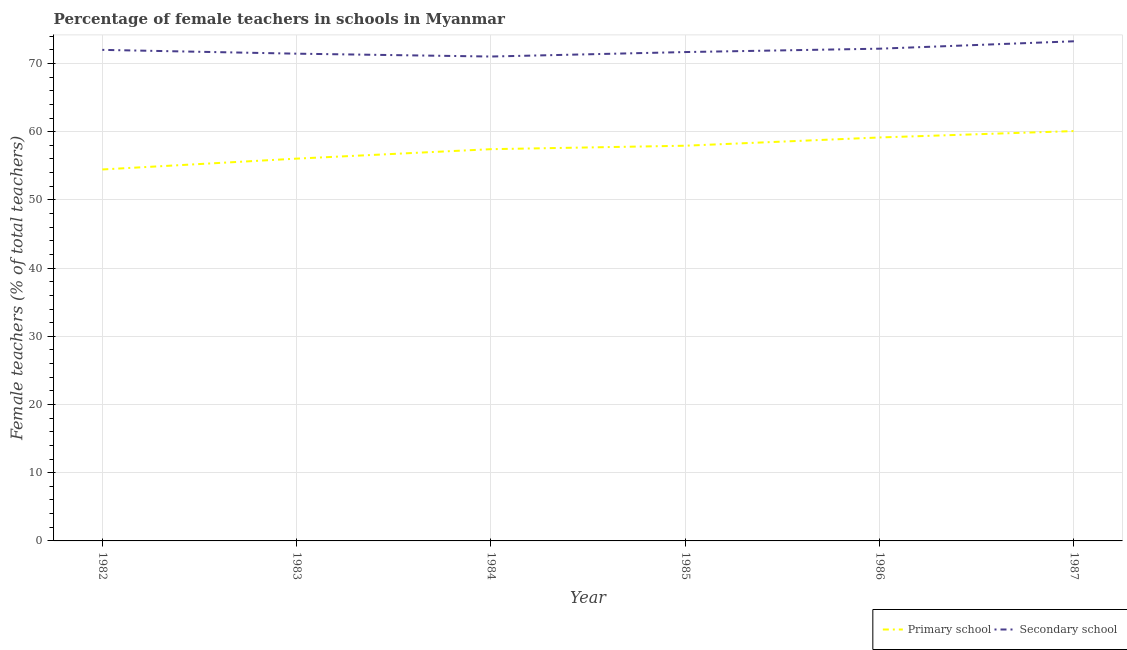Does the line corresponding to percentage of female teachers in secondary schools intersect with the line corresponding to percentage of female teachers in primary schools?
Offer a very short reply. No. What is the percentage of female teachers in primary schools in 1982?
Offer a very short reply. 54.46. Across all years, what is the maximum percentage of female teachers in secondary schools?
Offer a very short reply. 73.25. Across all years, what is the minimum percentage of female teachers in primary schools?
Provide a succinct answer. 54.46. In which year was the percentage of female teachers in secondary schools maximum?
Ensure brevity in your answer.  1987. What is the total percentage of female teachers in primary schools in the graph?
Keep it short and to the point. 345.13. What is the difference between the percentage of female teachers in secondary schools in 1984 and that in 1985?
Ensure brevity in your answer.  -0.66. What is the difference between the percentage of female teachers in primary schools in 1985 and the percentage of female teachers in secondary schools in 1983?
Offer a terse response. -13.49. What is the average percentage of female teachers in secondary schools per year?
Your answer should be very brief. 71.92. In the year 1982, what is the difference between the percentage of female teachers in secondary schools and percentage of female teachers in primary schools?
Your answer should be very brief. 17.53. What is the ratio of the percentage of female teachers in primary schools in 1982 to that in 1983?
Provide a succinct answer. 0.97. Is the percentage of female teachers in primary schools in 1985 less than that in 1987?
Offer a very short reply. Yes. What is the difference between the highest and the second highest percentage of female teachers in primary schools?
Your response must be concise. 0.94. What is the difference between the highest and the lowest percentage of female teachers in primary schools?
Make the answer very short. 5.63. Does the percentage of female teachers in secondary schools monotonically increase over the years?
Your answer should be compact. No. Is the percentage of female teachers in primary schools strictly less than the percentage of female teachers in secondary schools over the years?
Your answer should be very brief. Yes. How many years are there in the graph?
Keep it short and to the point. 6. Where does the legend appear in the graph?
Provide a succinct answer. Bottom right. How many legend labels are there?
Provide a succinct answer. 2. What is the title of the graph?
Offer a terse response. Percentage of female teachers in schools in Myanmar. What is the label or title of the X-axis?
Your answer should be very brief. Year. What is the label or title of the Y-axis?
Your answer should be very brief. Female teachers (% of total teachers). What is the Female teachers (% of total teachers) of Primary school in 1982?
Ensure brevity in your answer.  54.46. What is the Female teachers (% of total teachers) of Secondary school in 1982?
Provide a short and direct response. 71.99. What is the Female teachers (% of total teachers) of Primary school in 1983?
Ensure brevity in your answer.  56.05. What is the Female teachers (% of total teachers) in Secondary school in 1983?
Provide a succinct answer. 71.44. What is the Female teachers (% of total teachers) of Primary school in 1984?
Make the answer very short. 57.43. What is the Female teachers (% of total teachers) of Secondary school in 1984?
Your answer should be very brief. 71.02. What is the Female teachers (% of total teachers) in Primary school in 1985?
Provide a succinct answer. 57.94. What is the Female teachers (% of total teachers) of Secondary school in 1985?
Your answer should be compact. 71.67. What is the Female teachers (% of total teachers) of Primary school in 1986?
Your response must be concise. 59.15. What is the Female teachers (% of total teachers) in Secondary school in 1986?
Make the answer very short. 72.17. What is the Female teachers (% of total teachers) in Primary school in 1987?
Offer a very short reply. 60.09. What is the Female teachers (% of total teachers) in Secondary school in 1987?
Provide a succinct answer. 73.25. Across all years, what is the maximum Female teachers (% of total teachers) in Primary school?
Ensure brevity in your answer.  60.09. Across all years, what is the maximum Female teachers (% of total teachers) of Secondary school?
Offer a terse response. 73.25. Across all years, what is the minimum Female teachers (% of total teachers) in Primary school?
Keep it short and to the point. 54.46. Across all years, what is the minimum Female teachers (% of total teachers) of Secondary school?
Your answer should be compact. 71.02. What is the total Female teachers (% of total teachers) of Primary school in the graph?
Give a very brief answer. 345.13. What is the total Female teachers (% of total teachers) in Secondary school in the graph?
Give a very brief answer. 431.54. What is the difference between the Female teachers (% of total teachers) of Primary school in 1982 and that in 1983?
Give a very brief answer. -1.59. What is the difference between the Female teachers (% of total teachers) in Secondary school in 1982 and that in 1983?
Offer a terse response. 0.56. What is the difference between the Female teachers (% of total teachers) in Primary school in 1982 and that in 1984?
Your answer should be very brief. -2.97. What is the difference between the Female teachers (% of total teachers) in Secondary school in 1982 and that in 1984?
Your answer should be compact. 0.98. What is the difference between the Female teachers (% of total teachers) of Primary school in 1982 and that in 1985?
Provide a succinct answer. -3.48. What is the difference between the Female teachers (% of total teachers) of Secondary school in 1982 and that in 1985?
Your answer should be compact. 0.32. What is the difference between the Female teachers (% of total teachers) of Primary school in 1982 and that in 1986?
Make the answer very short. -4.69. What is the difference between the Female teachers (% of total teachers) in Secondary school in 1982 and that in 1986?
Give a very brief answer. -0.17. What is the difference between the Female teachers (% of total teachers) of Primary school in 1982 and that in 1987?
Your answer should be very brief. -5.63. What is the difference between the Female teachers (% of total teachers) of Secondary school in 1982 and that in 1987?
Provide a succinct answer. -1.26. What is the difference between the Female teachers (% of total teachers) of Primary school in 1983 and that in 1984?
Your answer should be very brief. -1.39. What is the difference between the Female teachers (% of total teachers) in Secondary school in 1983 and that in 1984?
Your response must be concise. 0.42. What is the difference between the Female teachers (% of total teachers) in Primary school in 1983 and that in 1985?
Provide a short and direct response. -1.89. What is the difference between the Female teachers (% of total teachers) of Secondary school in 1983 and that in 1985?
Make the answer very short. -0.24. What is the difference between the Female teachers (% of total teachers) in Primary school in 1983 and that in 1986?
Make the answer very short. -3.1. What is the difference between the Female teachers (% of total teachers) of Secondary school in 1983 and that in 1986?
Ensure brevity in your answer.  -0.73. What is the difference between the Female teachers (% of total teachers) of Primary school in 1983 and that in 1987?
Provide a succinct answer. -4.04. What is the difference between the Female teachers (% of total teachers) of Secondary school in 1983 and that in 1987?
Offer a very short reply. -1.82. What is the difference between the Female teachers (% of total teachers) of Primary school in 1984 and that in 1985?
Make the answer very short. -0.51. What is the difference between the Female teachers (% of total teachers) of Secondary school in 1984 and that in 1985?
Ensure brevity in your answer.  -0.66. What is the difference between the Female teachers (% of total teachers) of Primary school in 1984 and that in 1986?
Your answer should be very brief. -1.72. What is the difference between the Female teachers (% of total teachers) in Secondary school in 1984 and that in 1986?
Your answer should be very brief. -1.15. What is the difference between the Female teachers (% of total teachers) of Primary school in 1984 and that in 1987?
Make the answer very short. -2.66. What is the difference between the Female teachers (% of total teachers) of Secondary school in 1984 and that in 1987?
Your answer should be compact. -2.24. What is the difference between the Female teachers (% of total teachers) of Primary school in 1985 and that in 1986?
Give a very brief answer. -1.21. What is the difference between the Female teachers (% of total teachers) of Secondary school in 1985 and that in 1986?
Provide a short and direct response. -0.5. What is the difference between the Female teachers (% of total teachers) of Primary school in 1985 and that in 1987?
Keep it short and to the point. -2.15. What is the difference between the Female teachers (% of total teachers) in Secondary school in 1985 and that in 1987?
Make the answer very short. -1.58. What is the difference between the Female teachers (% of total teachers) in Primary school in 1986 and that in 1987?
Your answer should be compact. -0.94. What is the difference between the Female teachers (% of total teachers) in Secondary school in 1986 and that in 1987?
Provide a succinct answer. -1.08. What is the difference between the Female teachers (% of total teachers) in Primary school in 1982 and the Female teachers (% of total teachers) in Secondary school in 1983?
Your answer should be very brief. -16.98. What is the difference between the Female teachers (% of total teachers) in Primary school in 1982 and the Female teachers (% of total teachers) in Secondary school in 1984?
Provide a succinct answer. -16.56. What is the difference between the Female teachers (% of total teachers) of Primary school in 1982 and the Female teachers (% of total teachers) of Secondary school in 1985?
Give a very brief answer. -17.21. What is the difference between the Female teachers (% of total teachers) of Primary school in 1982 and the Female teachers (% of total teachers) of Secondary school in 1986?
Your response must be concise. -17.71. What is the difference between the Female teachers (% of total teachers) of Primary school in 1982 and the Female teachers (% of total teachers) of Secondary school in 1987?
Ensure brevity in your answer.  -18.79. What is the difference between the Female teachers (% of total teachers) of Primary school in 1983 and the Female teachers (% of total teachers) of Secondary school in 1984?
Ensure brevity in your answer.  -14.97. What is the difference between the Female teachers (% of total teachers) in Primary school in 1983 and the Female teachers (% of total teachers) in Secondary school in 1985?
Your answer should be compact. -15.62. What is the difference between the Female teachers (% of total teachers) in Primary school in 1983 and the Female teachers (% of total teachers) in Secondary school in 1986?
Keep it short and to the point. -16.12. What is the difference between the Female teachers (% of total teachers) of Primary school in 1983 and the Female teachers (% of total teachers) of Secondary school in 1987?
Your answer should be very brief. -17.2. What is the difference between the Female teachers (% of total teachers) of Primary school in 1984 and the Female teachers (% of total teachers) of Secondary school in 1985?
Offer a terse response. -14.24. What is the difference between the Female teachers (% of total teachers) of Primary school in 1984 and the Female teachers (% of total teachers) of Secondary school in 1986?
Your answer should be compact. -14.73. What is the difference between the Female teachers (% of total teachers) of Primary school in 1984 and the Female teachers (% of total teachers) of Secondary school in 1987?
Your response must be concise. -15.82. What is the difference between the Female teachers (% of total teachers) of Primary school in 1985 and the Female teachers (% of total teachers) of Secondary school in 1986?
Offer a terse response. -14.23. What is the difference between the Female teachers (% of total teachers) of Primary school in 1985 and the Female teachers (% of total teachers) of Secondary school in 1987?
Your response must be concise. -15.31. What is the difference between the Female teachers (% of total teachers) in Primary school in 1986 and the Female teachers (% of total teachers) in Secondary school in 1987?
Provide a succinct answer. -14.1. What is the average Female teachers (% of total teachers) in Primary school per year?
Your answer should be compact. 57.52. What is the average Female teachers (% of total teachers) of Secondary school per year?
Make the answer very short. 71.92. In the year 1982, what is the difference between the Female teachers (% of total teachers) in Primary school and Female teachers (% of total teachers) in Secondary school?
Offer a terse response. -17.53. In the year 1983, what is the difference between the Female teachers (% of total teachers) of Primary school and Female teachers (% of total teachers) of Secondary school?
Provide a succinct answer. -15.39. In the year 1984, what is the difference between the Female teachers (% of total teachers) of Primary school and Female teachers (% of total teachers) of Secondary school?
Offer a terse response. -13.58. In the year 1985, what is the difference between the Female teachers (% of total teachers) in Primary school and Female teachers (% of total teachers) in Secondary school?
Your answer should be very brief. -13.73. In the year 1986, what is the difference between the Female teachers (% of total teachers) of Primary school and Female teachers (% of total teachers) of Secondary school?
Your response must be concise. -13.02. In the year 1987, what is the difference between the Female teachers (% of total teachers) of Primary school and Female teachers (% of total teachers) of Secondary school?
Offer a terse response. -13.16. What is the ratio of the Female teachers (% of total teachers) of Primary school in 1982 to that in 1983?
Your answer should be very brief. 0.97. What is the ratio of the Female teachers (% of total teachers) of Secondary school in 1982 to that in 1983?
Give a very brief answer. 1.01. What is the ratio of the Female teachers (% of total teachers) in Primary school in 1982 to that in 1984?
Make the answer very short. 0.95. What is the ratio of the Female teachers (% of total teachers) in Secondary school in 1982 to that in 1984?
Your response must be concise. 1.01. What is the ratio of the Female teachers (% of total teachers) in Primary school in 1982 to that in 1985?
Keep it short and to the point. 0.94. What is the ratio of the Female teachers (% of total teachers) in Primary school in 1982 to that in 1986?
Give a very brief answer. 0.92. What is the ratio of the Female teachers (% of total teachers) in Primary school in 1982 to that in 1987?
Provide a succinct answer. 0.91. What is the ratio of the Female teachers (% of total teachers) of Secondary school in 1982 to that in 1987?
Provide a short and direct response. 0.98. What is the ratio of the Female teachers (% of total teachers) of Primary school in 1983 to that in 1984?
Make the answer very short. 0.98. What is the ratio of the Female teachers (% of total teachers) of Secondary school in 1983 to that in 1984?
Your answer should be very brief. 1.01. What is the ratio of the Female teachers (% of total teachers) in Primary school in 1983 to that in 1985?
Provide a succinct answer. 0.97. What is the ratio of the Female teachers (% of total teachers) of Primary school in 1983 to that in 1986?
Your answer should be very brief. 0.95. What is the ratio of the Female teachers (% of total teachers) in Secondary school in 1983 to that in 1986?
Ensure brevity in your answer.  0.99. What is the ratio of the Female teachers (% of total teachers) of Primary school in 1983 to that in 1987?
Keep it short and to the point. 0.93. What is the ratio of the Female teachers (% of total teachers) in Secondary school in 1983 to that in 1987?
Ensure brevity in your answer.  0.98. What is the ratio of the Female teachers (% of total teachers) of Secondary school in 1984 to that in 1985?
Your response must be concise. 0.99. What is the ratio of the Female teachers (% of total teachers) of Primary school in 1984 to that in 1986?
Offer a terse response. 0.97. What is the ratio of the Female teachers (% of total teachers) of Secondary school in 1984 to that in 1986?
Your answer should be compact. 0.98. What is the ratio of the Female teachers (% of total teachers) of Primary school in 1984 to that in 1987?
Your answer should be compact. 0.96. What is the ratio of the Female teachers (% of total teachers) of Secondary school in 1984 to that in 1987?
Keep it short and to the point. 0.97. What is the ratio of the Female teachers (% of total teachers) of Primary school in 1985 to that in 1986?
Offer a terse response. 0.98. What is the ratio of the Female teachers (% of total teachers) of Secondary school in 1985 to that in 1986?
Your answer should be very brief. 0.99. What is the ratio of the Female teachers (% of total teachers) of Primary school in 1985 to that in 1987?
Offer a terse response. 0.96. What is the ratio of the Female teachers (% of total teachers) in Secondary school in 1985 to that in 1987?
Make the answer very short. 0.98. What is the ratio of the Female teachers (% of total teachers) of Primary school in 1986 to that in 1987?
Give a very brief answer. 0.98. What is the ratio of the Female teachers (% of total teachers) in Secondary school in 1986 to that in 1987?
Your response must be concise. 0.99. What is the difference between the highest and the second highest Female teachers (% of total teachers) in Primary school?
Provide a short and direct response. 0.94. What is the difference between the highest and the second highest Female teachers (% of total teachers) in Secondary school?
Give a very brief answer. 1.08. What is the difference between the highest and the lowest Female teachers (% of total teachers) in Primary school?
Make the answer very short. 5.63. What is the difference between the highest and the lowest Female teachers (% of total teachers) of Secondary school?
Your answer should be compact. 2.24. 